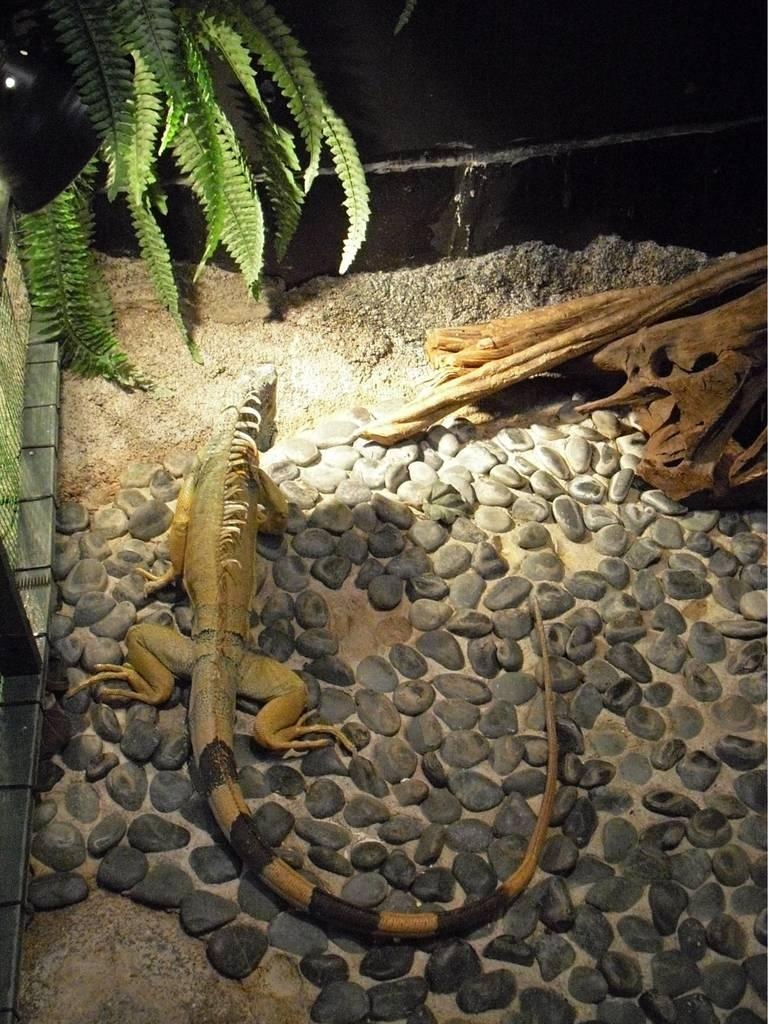What type of animal is in the image? There is a reptile in the image. What other living organism is in the image? There is a plant in the image. What else can be seen on the ground in the image? There are other objects on the ground in the image. What type of gate can be seen in the image? There is no gate present in the image. How many flies are visible in the image? There are no flies present in the image. 